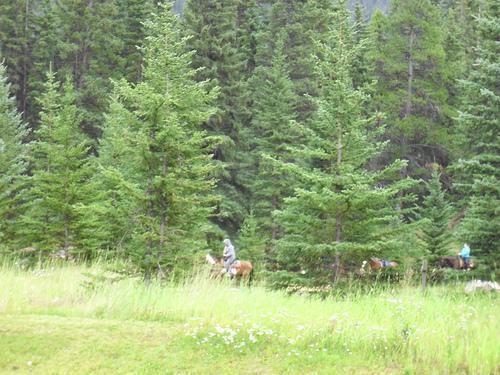How many horses are there?
Give a very brief answer. 3. 